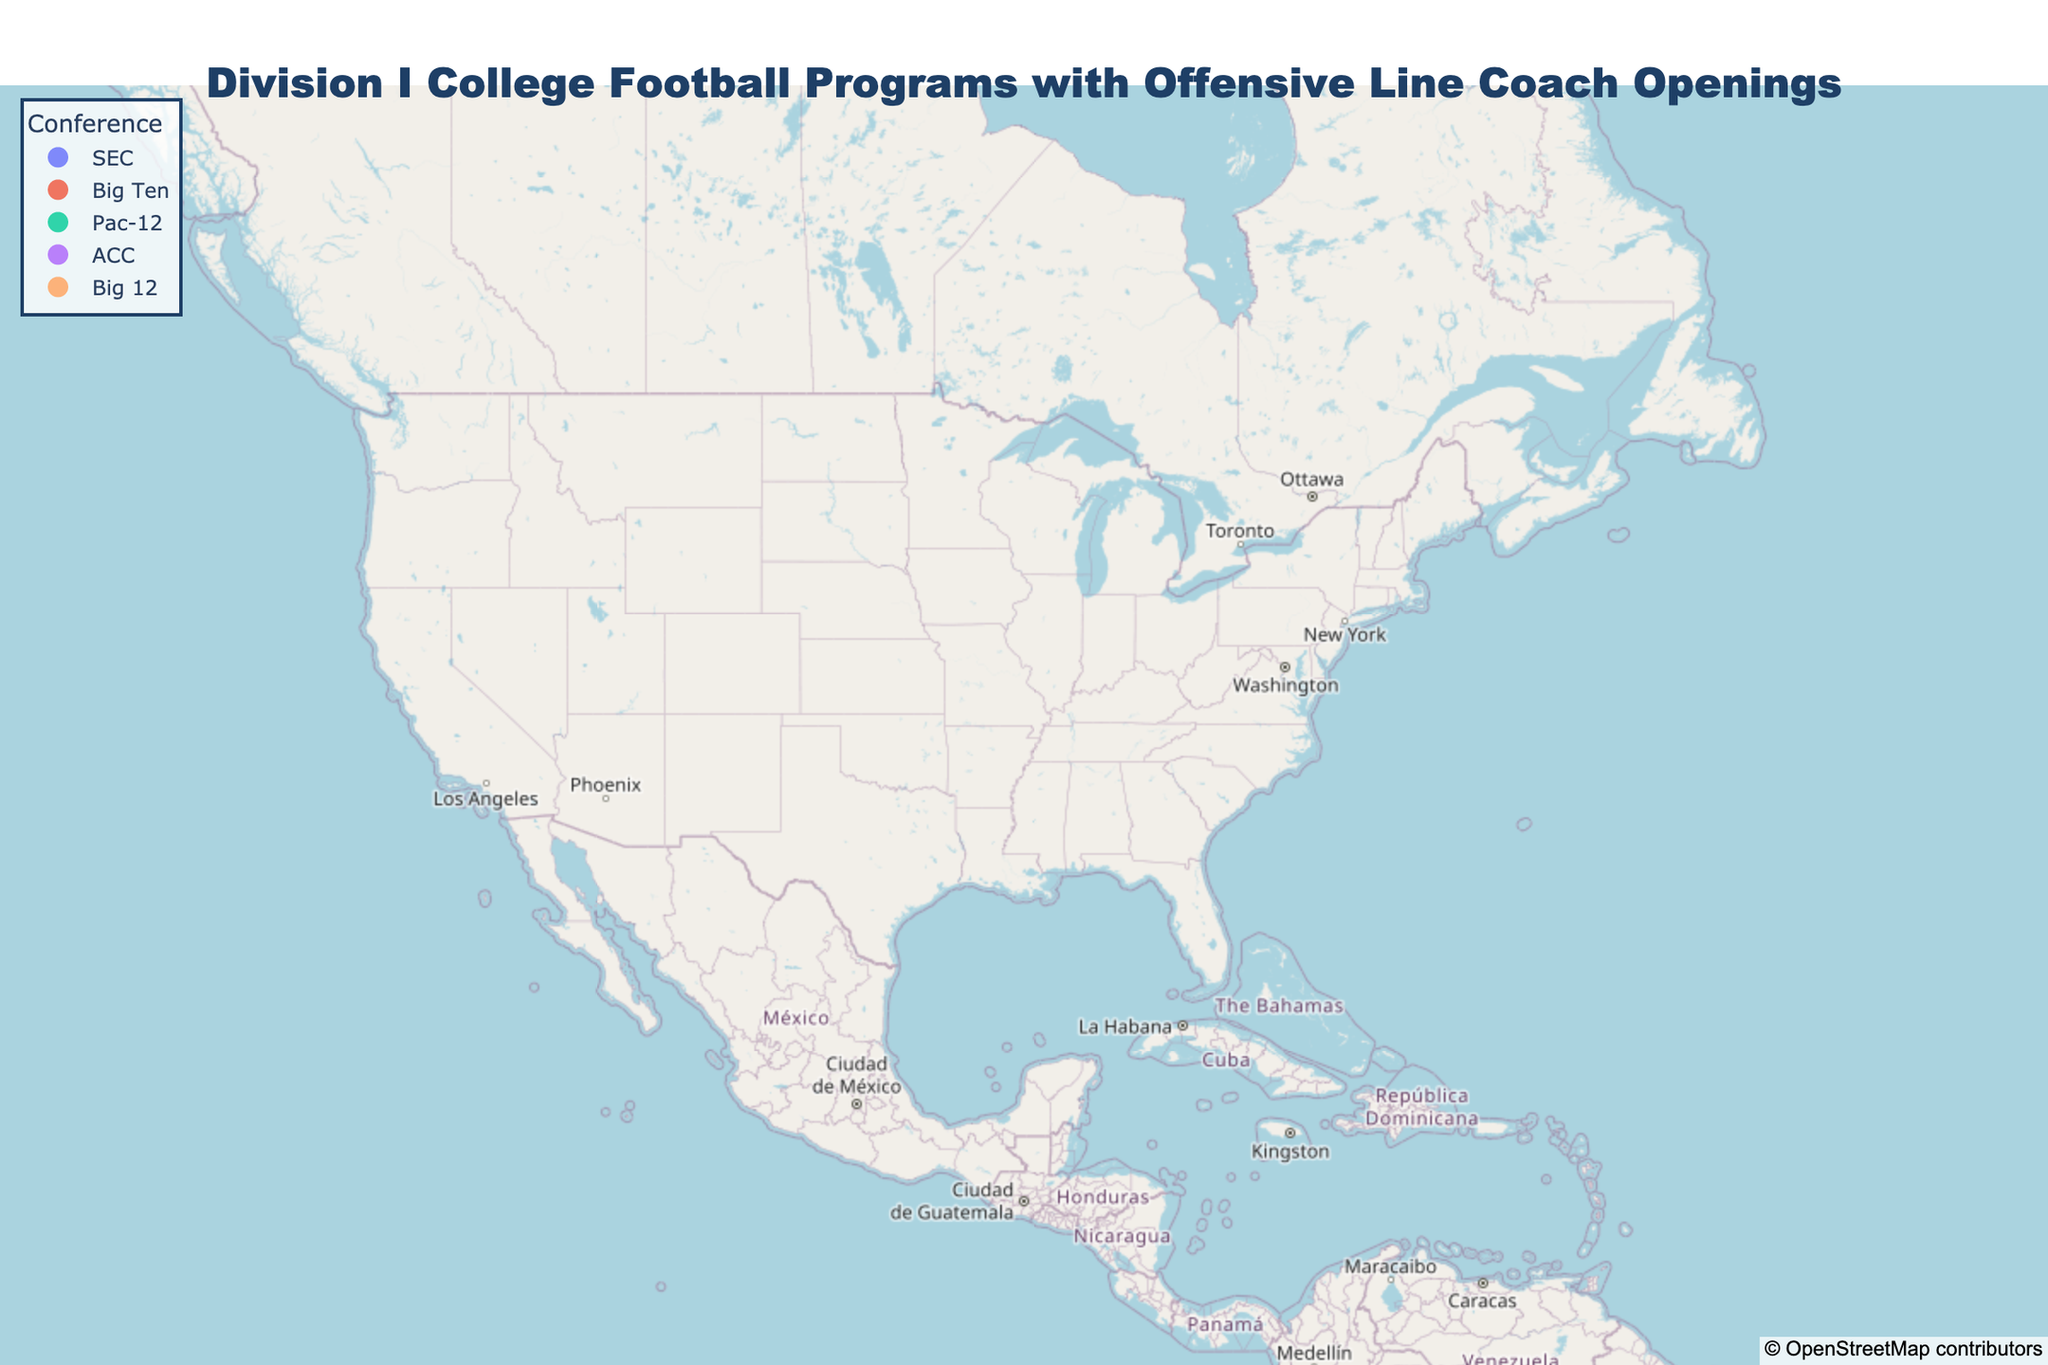How many Division I college football programs with offensive line coach openings are displayed on the plot? Count the number of data points (markers) on the map. Each marker represents a school with an opening.
Answer: 12 What is the northernmost school shown on the plot? Identify the school located at the highest latitude among all the plotted points.
Answer: University of Wisconsin Which school is located in the largest state by land area among those in the figure? Check the states displayed and determine which school is in Texas, the largest state by land area in the data.
Answer: University of Texas How many schools belong to the Big Ten conference? Identify and count the markers colored to represent the Big Ten conference in the legend and map.
Answer: 4 What is the westernmost school on the map? Identify the school with the lowest longitude value among all the plotted points.
Answer: University of Oregon Which school's marker is located furthest from the others in terms of geographic spread? Compare the relative positions of all markers and identify the one that appears to be the most isolated.
Answer: University of Oregon Which conference has the most schools with offensive line coach openings represented in the plot? Look at the legend and count the number of schools for each conference by their colors and determine the highest count.
Answer: Big Ten Which state has the highest number of schools with offensive line coach openings in this plot? Identify the school locations and determine which state appears most frequently.
Answer: Texas What is the average latitude of all the schools displayed? Add up the latitude values of all the plotted points and divide by the total number of schools.
Answer: 37.1088 Which two schools are closest to each other on the map? Visually compare the distances between all pairs of neighboring schools and identify the ones closest together.
Answer: University of Texas and Texas A&M University 